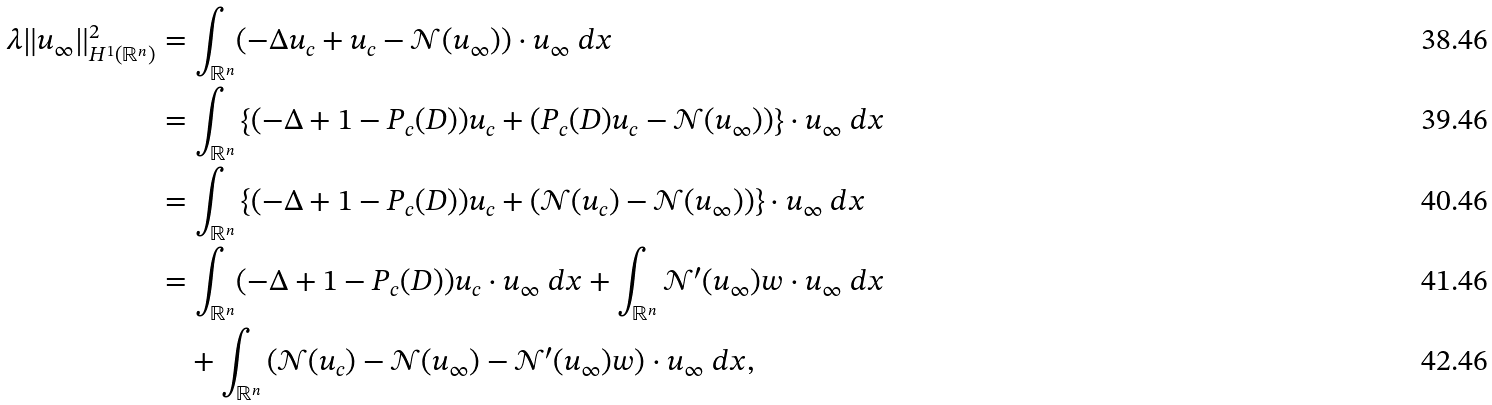Convert formula to latex. <formula><loc_0><loc_0><loc_500><loc_500>\lambda \| u _ { \infty } \| _ { H ^ { 1 } ( \mathbb { R } ^ { n } ) } ^ { 2 } & = \int _ { \mathbb { R } ^ { n } } ( - \Delta u _ { c } + u _ { c } - \mathcal { N } ( u _ { \infty } ) ) \cdot u _ { \infty } \ d x \\ & = \int _ { \mathbb { R } ^ { n } } \left \{ ( - \Delta + 1 - P _ { c } ( D ) ) u _ { c } + ( P _ { c } ( D ) u _ { c } - \mathcal { N } ( u _ { \infty } ) ) \right \} \cdot u _ { \infty } \ d x \\ & = \int _ { \mathbb { R } ^ { n } } \left \{ ( - \Delta + 1 - P _ { c } ( D ) ) u _ { c } + ( \mathcal { N } ( u _ { c } ) - \mathcal { N } ( u _ { \infty } ) ) \right \} \cdot u _ { \infty } \ d x \\ & = \int _ { \mathbb { R } ^ { n } } ( - \Delta + 1 - P _ { c } ( D ) ) u _ { c } \cdot u _ { \infty } \ d x + \int _ { \mathbb { R } ^ { n } } \mathcal { N } ^ { \prime } ( u _ { \infty } ) w \cdot u _ { \infty } \ d x \\ & \quad + \int _ { \mathbb { R } ^ { n } } \left ( \mathcal { N } ( u _ { c } ) - \mathcal { N } ( u _ { \infty } ) - \mathcal { N } ^ { \prime } ( u _ { \infty } ) w \right ) \cdot u _ { \infty } \ d x ,</formula> 